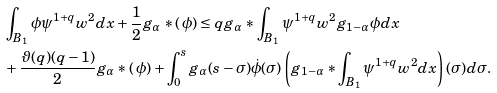Convert formula to latex. <formula><loc_0><loc_0><loc_500><loc_500>& \int _ { B _ { 1 } } \phi \psi ^ { 1 + q } w ^ { 2 } d x + \frac { 1 } { 2 } g _ { \alpha } * ( \, \phi ) \leq q g _ { \alpha } * \int _ { B _ { 1 } } \psi ^ { 1 + q } w ^ { 2 } g _ { 1 - \alpha } \phi d x \\ & + \frac { \vartheta ( q ) ( q - 1 ) } { 2 } g _ { \alpha } * ( \, \phi ) + \int _ { 0 } ^ { s } g _ { \alpha } ( s - \sigma ) \dot { \phi } ( \sigma ) \left ( g _ { 1 - \alpha } * \int _ { B _ { 1 } } \psi ^ { 1 + q } w ^ { 2 } d x \right ) ( \sigma ) d \sigma .</formula> 